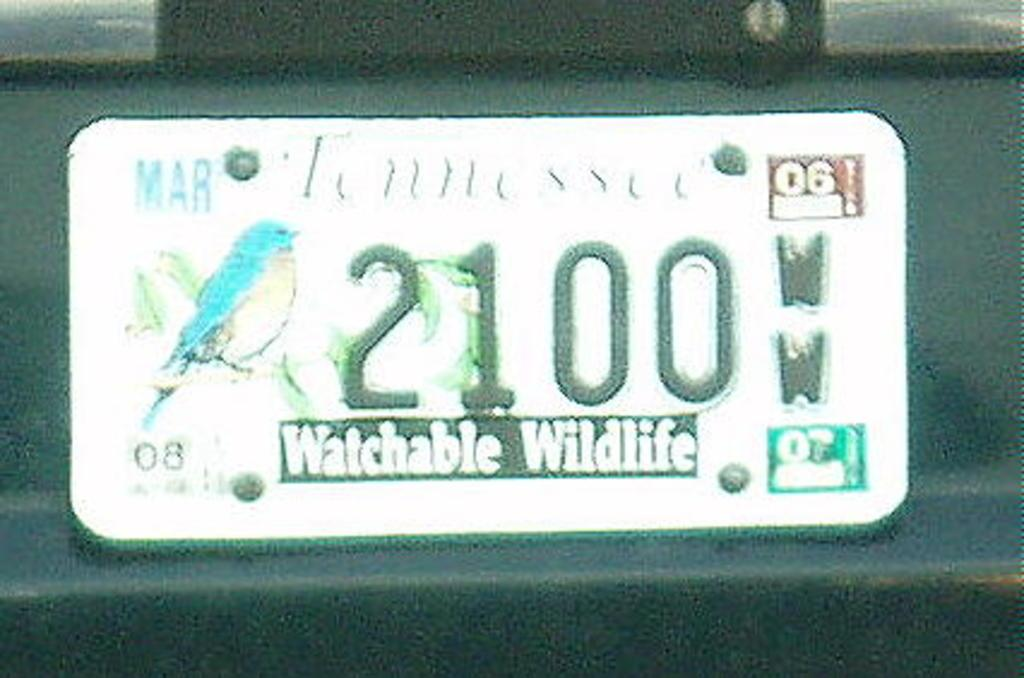What is the main object in the image? There is a board in the image. What can be seen on the board? The board has some text on it. How many people are sitting on the seat in the image? There is no seat present in the image; it only features a board with text on it. 